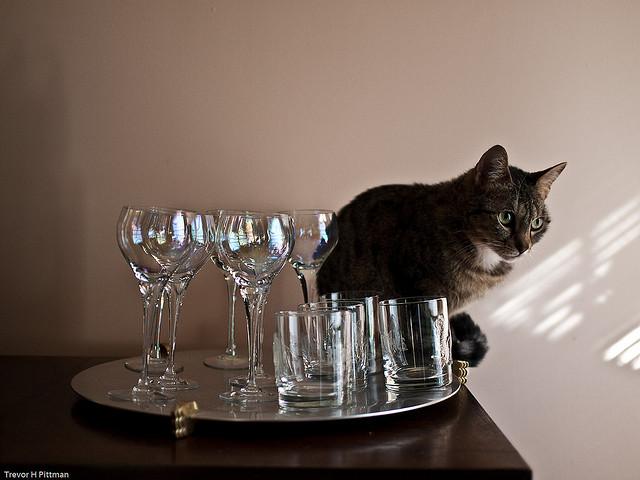Is this cat planning to break the glasses?
Write a very short answer. No. What is shining on the wall?
Short answer required. Sun. How many glasses are there?
Quick response, please. 11. What is the cat looking at?
Concise answer only. Window. 